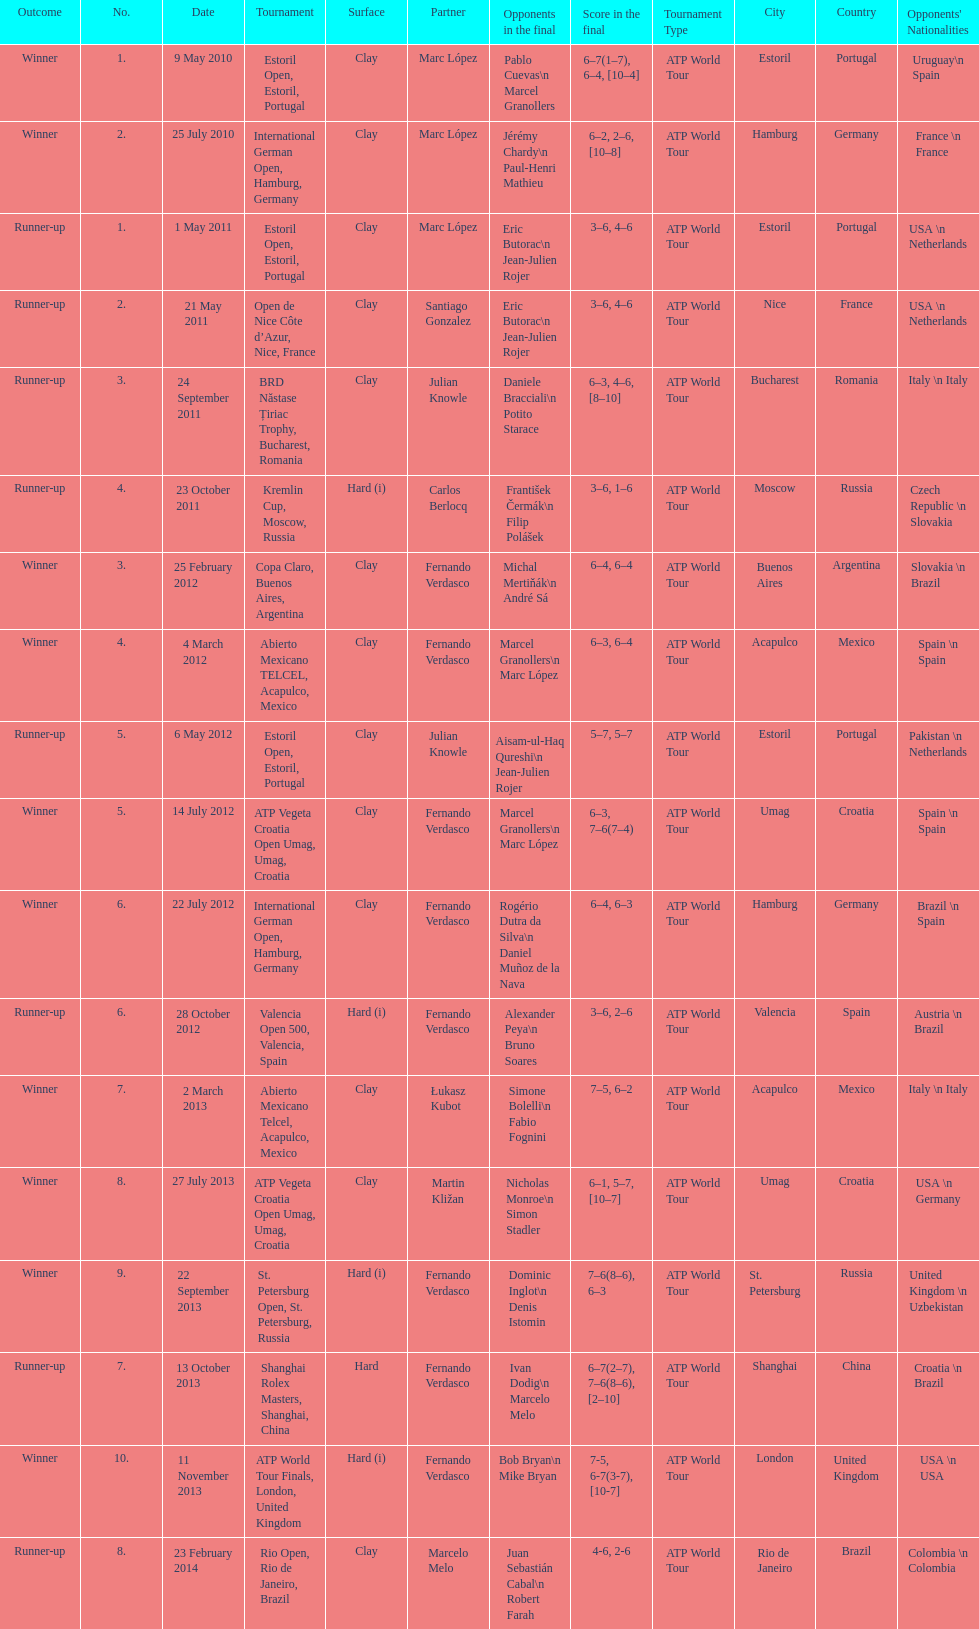Who was this player's next partner after playing with marc lopez in may 2011? Santiago Gonzalez. Help me parse the entirety of this table. {'header': ['Outcome', 'No.', 'Date', 'Tournament', 'Surface', 'Partner', 'Opponents in the final', 'Score in the final', 'Tournament Type', 'City', 'Country', "Opponents' Nationalities"], 'rows': [['Winner', '1.', '9 May 2010', 'Estoril Open, Estoril, Portugal', 'Clay', 'Marc López', 'Pablo Cuevas\\n Marcel Granollers', '6–7(1–7), 6–4, [10–4]', 'ATP World Tour', 'Estoril', 'Portugal', 'Uruguay\\n Spain'], ['Winner', '2.', '25 July 2010', 'International German Open, Hamburg, Germany', 'Clay', 'Marc López', 'Jérémy Chardy\\n Paul-Henri Mathieu', '6–2, 2–6, [10–8]', 'ATP World Tour', 'Hamburg', 'Germany', 'France \\n France'], ['Runner-up', '1.', '1 May 2011', 'Estoril Open, Estoril, Portugal', 'Clay', 'Marc López', 'Eric Butorac\\n Jean-Julien Rojer', '3–6, 4–6', 'ATP World Tour', 'Estoril', 'Portugal', 'USA \\n Netherlands'], ['Runner-up', '2.', '21 May 2011', 'Open de Nice Côte d’Azur, Nice, France', 'Clay', 'Santiago Gonzalez', 'Eric Butorac\\n Jean-Julien Rojer', '3–6, 4–6', 'ATP World Tour', 'Nice', 'France', 'USA \\n Netherlands'], ['Runner-up', '3.', '24 September 2011', 'BRD Năstase Țiriac Trophy, Bucharest, Romania', 'Clay', 'Julian Knowle', 'Daniele Bracciali\\n Potito Starace', '6–3, 4–6, [8–10]', 'ATP World Tour', 'Bucharest', 'Romania', 'Italy \\n Italy'], ['Runner-up', '4.', '23 October 2011', 'Kremlin Cup, Moscow, Russia', 'Hard (i)', 'Carlos Berlocq', 'František Čermák\\n Filip Polášek', '3–6, 1–6', 'ATP World Tour', 'Moscow', 'Russia', 'Czech Republic \\n Slovakia'], ['Winner', '3.', '25 February 2012', 'Copa Claro, Buenos Aires, Argentina', 'Clay', 'Fernando Verdasco', 'Michal Mertiňák\\n André Sá', '6–4, 6–4', 'ATP World Tour', 'Buenos Aires', 'Argentina', 'Slovakia \\n Brazil'], ['Winner', '4.', '4 March 2012', 'Abierto Mexicano TELCEL, Acapulco, Mexico', 'Clay', 'Fernando Verdasco', 'Marcel Granollers\\n Marc López', '6–3, 6–4', 'ATP World Tour', 'Acapulco', 'Mexico', 'Spain \\n Spain'], ['Runner-up', '5.', '6 May 2012', 'Estoril Open, Estoril, Portugal', 'Clay', 'Julian Knowle', 'Aisam-ul-Haq Qureshi\\n Jean-Julien Rojer', '5–7, 5–7', 'ATP World Tour', 'Estoril', 'Portugal', 'Pakistan \\n Netherlands'], ['Winner', '5.', '14 July 2012', 'ATP Vegeta Croatia Open Umag, Umag, Croatia', 'Clay', 'Fernando Verdasco', 'Marcel Granollers\\n Marc López', '6–3, 7–6(7–4)', 'ATP World Tour', 'Umag', 'Croatia', 'Spain \\n Spain'], ['Winner', '6.', '22 July 2012', 'International German Open, Hamburg, Germany', 'Clay', 'Fernando Verdasco', 'Rogério Dutra da Silva\\n Daniel Muñoz de la Nava', '6–4, 6–3', 'ATP World Tour', 'Hamburg', 'Germany', 'Brazil \\n Spain'], ['Runner-up', '6.', '28 October 2012', 'Valencia Open 500, Valencia, Spain', 'Hard (i)', 'Fernando Verdasco', 'Alexander Peya\\n Bruno Soares', '3–6, 2–6', 'ATP World Tour', 'Valencia', 'Spain', 'Austria \\n Brazil'], ['Winner', '7.', '2 March 2013', 'Abierto Mexicano Telcel, Acapulco, Mexico', 'Clay', 'Łukasz Kubot', 'Simone Bolelli\\n Fabio Fognini', '7–5, 6–2', 'ATP World Tour', 'Acapulco', 'Mexico', 'Italy \\n Italy'], ['Winner', '8.', '27 July 2013', 'ATP Vegeta Croatia Open Umag, Umag, Croatia', 'Clay', 'Martin Kližan', 'Nicholas Monroe\\n Simon Stadler', '6–1, 5–7, [10–7]', 'ATP World Tour', 'Umag', 'Croatia', 'USA \\n Germany'], ['Winner', '9.', '22 September 2013', 'St. Petersburg Open, St. Petersburg, Russia', 'Hard (i)', 'Fernando Verdasco', 'Dominic Inglot\\n Denis Istomin', '7–6(8–6), 6–3', 'ATP World Tour', 'St. Petersburg', 'Russia', 'United Kingdom \\n Uzbekistan'], ['Runner-up', '7.', '13 October 2013', 'Shanghai Rolex Masters, Shanghai, China', 'Hard', 'Fernando Verdasco', 'Ivan Dodig\\n Marcelo Melo', '6–7(2–7), 7–6(8–6), [2–10]', 'ATP World Tour', 'Shanghai', 'China', 'Croatia \\n Brazil'], ['Winner', '10.', '11 November 2013', 'ATP World Tour Finals, London, United Kingdom', 'Hard (i)', 'Fernando Verdasco', 'Bob Bryan\\n Mike Bryan', '7-5, 6-7(3-7), [10-7]', 'ATP World Tour', 'London', 'United Kingdom', 'USA \\n USA'], ['Runner-up', '8.', '23 February 2014', 'Rio Open, Rio de Janeiro, Brazil', 'Clay', 'Marcelo Melo', 'Juan Sebastián Cabal\\n Robert Farah', '4-6, 2-6', 'ATP World Tour', 'Rio de Janeiro', 'Brazil', 'Colombia \\n Colombia']]} 